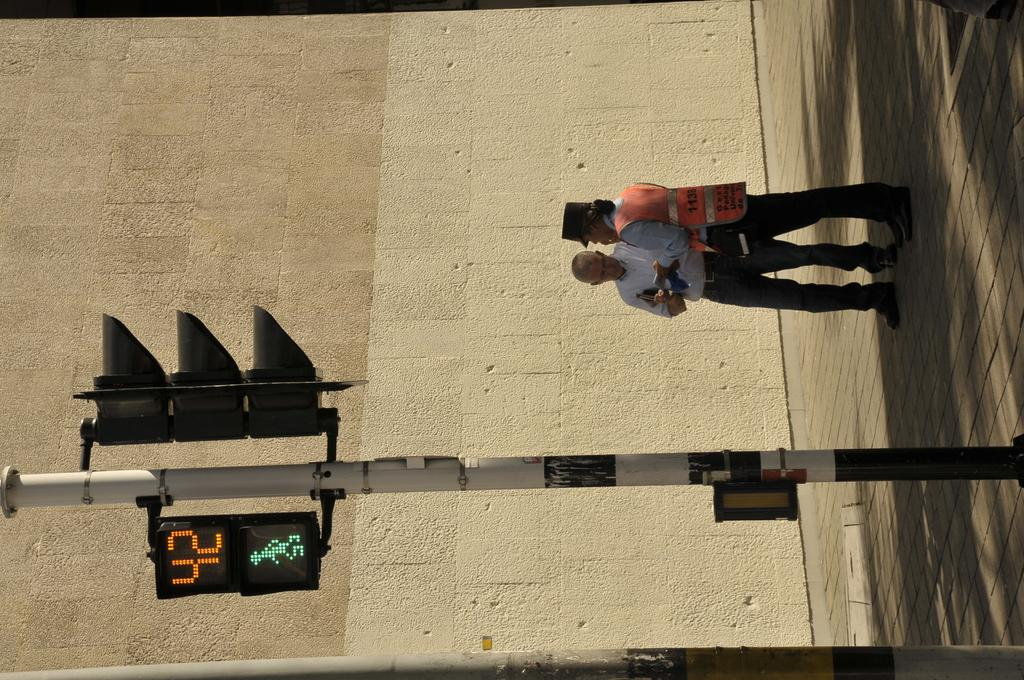Provide a one-sentence caption for the provided image. Pedestrians have 42 seconds to safely cross the street. 